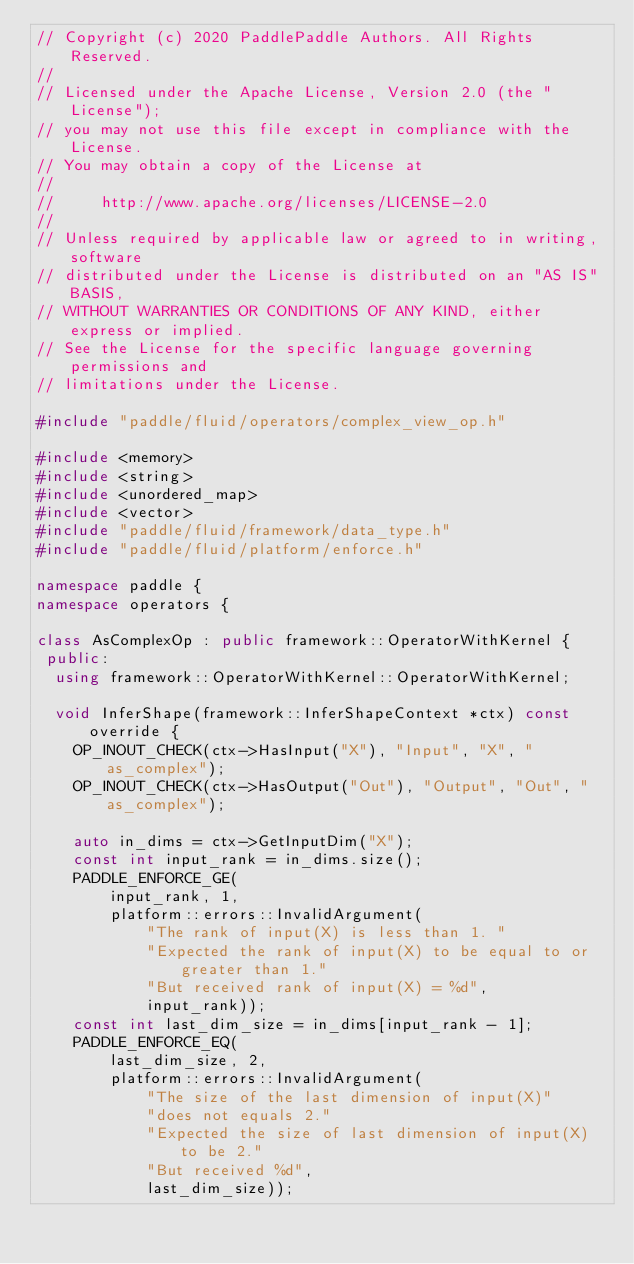Convert code to text. <code><loc_0><loc_0><loc_500><loc_500><_C++_>// Copyright (c) 2020 PaddlePaddle Authors. All Rights Reserved.
//
// Licensed under the Apache License, Version 2.0 (the "License");
// you may not use this file except in compliance with the License.
// You may obtain a copy of the License at
//
//     http://www.apache.org/licenses/LICENSE-2.0
//
// Unless required by applicable law or agreed to in writing, software
// distributed under the License is distributed on an "AS IS" BASIS,
// WITHOUT WARRANTIES OR CONDITIONS OF ANY KIND, either express or implied.
// See the License for the specific language governing permissions and
// limitations under the License.

#include "paddle/fluid/operators/complex_view_op.h"

#include <memory>
#include <string>
#include <unordered_map>
#include <vector>
#include "paddle/fluid/framework/data_type.h"
#include "paddle/fluid/platform/enforce.h"

namespace paddle {
namespace operators {

class AsComplexOp : public framework::OperatorWithKernel {
 public:
  using framework::OperatorWithKernel::OperatorWithKernel;

  void InferShape(framework::InferShapeContext *ctx) const override {
    OP_INOUT_CHECK(ctx->HasInput("X"), "Input", "X", "as_complex");
    OP_INOUT_CHECK(ctx->HasOutput("Out"), "Output", "Out", "as_complex");

    auto in_dims = ctx->GetInputDim("X");
    const int input_rank = in_dims.size();
    PADDLE_ENFORCE_GE(
        input_rank, 1,
        platform::errors::InvalidArgument(
            "The rank of input(X) is less than 1. "
            "Expected the rank of input(X) to be equal to or greater than 1."
            "But received rank of input(X) = %d",
            input_rank));
    const int last_dim_size = in_dims[input_rank - 1];
    PADDLE_ENFORCE_EQ(
        last_dim_size, 2,
        platform::errors::InvalidArgument(
            "The size of the last dimension of input(X)"
            "does not equals 2."
            "Expected the size of last dimension of input(X) to be 2."
            "But received %d",
            last_dim_size));
</code> 